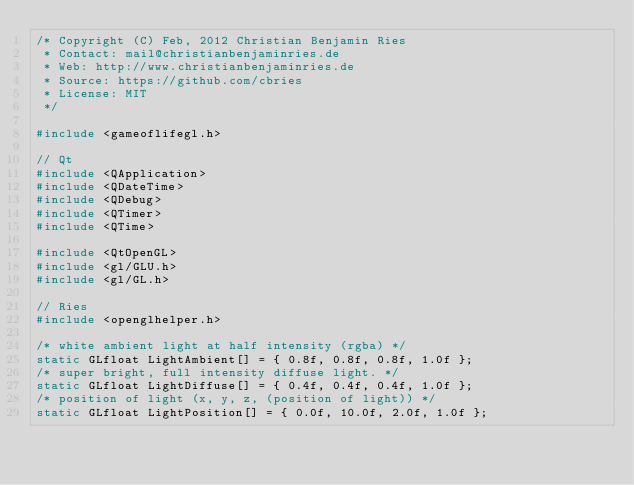Convert code to text. <code><loc_0><loc_0><loc_500><loc_500><_C++_>/* Copyright (C) Feb, 2012 Christian Benjamin Ries
 * Contact: mail@christianbenjaminries.de
 * Web: http://www.christianbenjaminries.de
 * Source: https://github.com/cbries
 * License: MIT
 */
 
#include <gameoflifegl.h>

// Qt
#include <QApplication>
#include <QDateTime>
#include <QDebug>
#include <QTimer>
#include <QTime>

#include <QtOpenGL>
#include <gl/GLU.h>
#include <gl/GL.h>

// Ries
#include <openglhelper.h>
  
/* white ambient light at half intensity (rgba) */
static GLfloat LightAmbient[] = { 0.8f, 0.8f, 0.8f, 1.0f };
/* super bright, full intensity diffuse light. */
static GLfloat LightDiffuse[] = { 0.4f, 0.4f, 0.4f, 1.0f };
/* position of light (x, y, z, (position of light)) */
static GLfloat LightPosition[] = { 0.0f, 10.0f, 2.0f, 1.0f };
</code> 